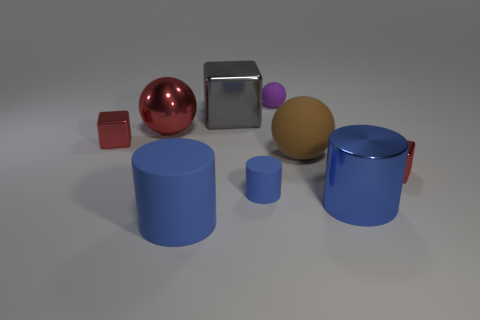There is a blue cylinder that is both in front of the tiny blue rubber cylinder and to the right of the large gray thing; what material is it?
Provide a short and direct response. Metal. Is the material of the large brown ball the same as the purple ball?
Ensure brevity in your answer.  Yes. Does the small cylinder have the same color as the shiny cylinder?
Offer a terse response. Yes. What is the shape of the big rubber object that is the same color as the small matte cylinder?
Make the answer very short. Cylinder. What is the shape of the blue shiny thing that is the same size as the gray thing?
Your answer should be very brief. Cylinder. What is the shape of the small object that is the same material as the tiny ball?
Provide a short and direct response. Cylinder. How many other things are there of the same size as the purple rubber thing?
Your answer should be very brief. 3. The other matte cylinder that is the same color as the small matte cylinder is what size?
Provide a short and direct response. Large. Does the large rubber object right of the tiny blue cylinder have the same shape as the tiny purple rubber object?
Your answer should be compact. Yes. How many other things are there of the same shape as the purple rubber thing?
Your answer should be compact. 2. 